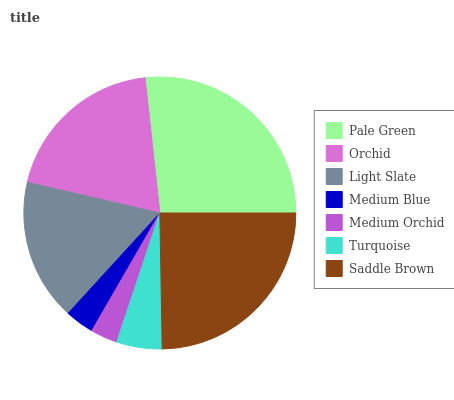Is Medium Orchid the minimum?
Answer yes or no. Yes. Is Pale Green the maximum?
Answer yes or no. Yes. Is Orchid the minimum?
Answer yes or no. No. Is Orchid the maximum?
Answer yes or no. No. Is Pale Green greater than Orchid?
Answer yes or no. Yes. Is Orchid less than Pale Green?
Answer yes or no. Yes. Is Orchid greater than Pale Green?
Answer yes or no. No. Is Pale Green less than Orchid?
Answer yes or no. No. Is Light Slate the high median?
Answer yes or no. Yes. Is Light Slate the low median?
Answer yes or no. Yes. Is Medium Orchid the high median?
Answer yes or no. No. Is Orchid the low median?
Answer yes or no. No. 